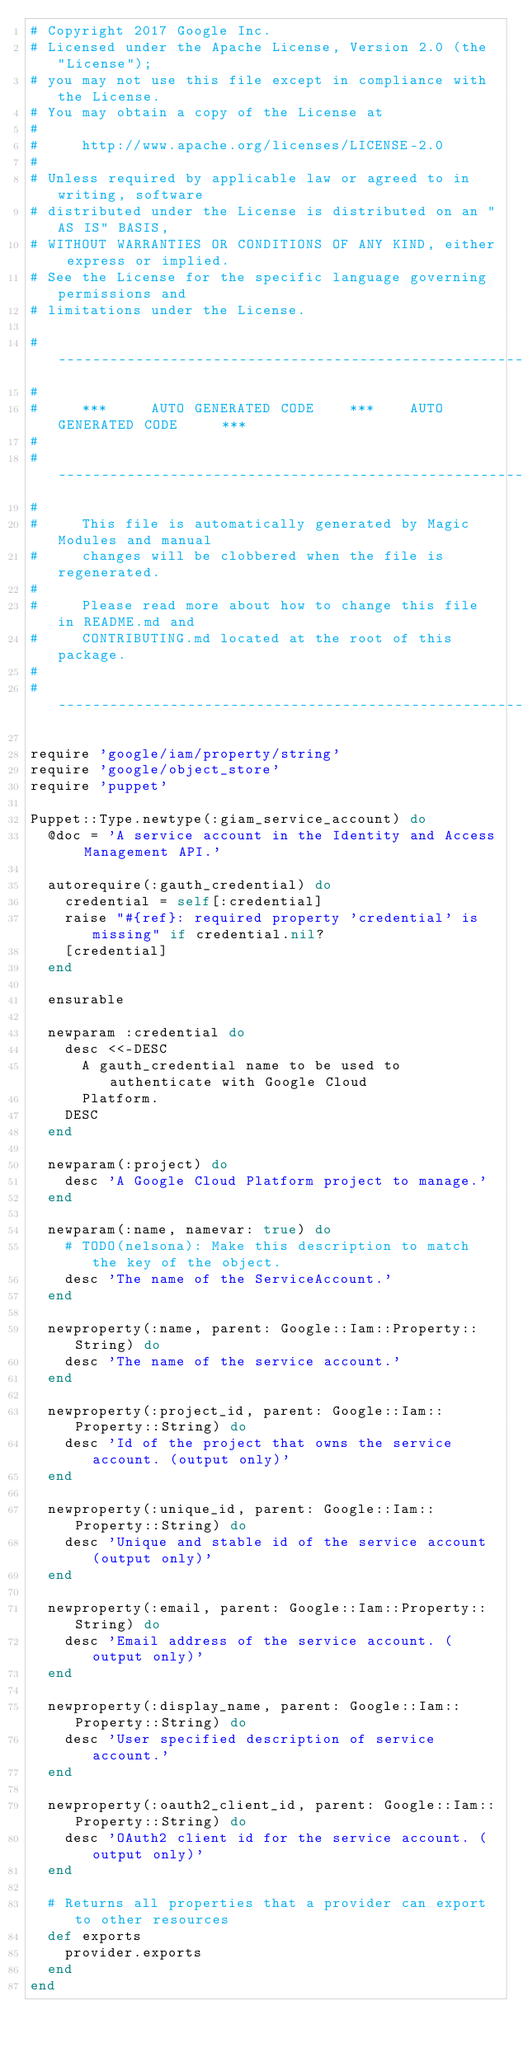<code> <loc_0><loc_0><loc_500><loc_500><_Ruby_># Copyright 2017 Google Inc.
# Licensed under the Apache License, Version 2.0 (the "License");
# you may not use this file except in compliance with the License.
# You may obtain a copy of the License at
#
#     http://www.apache.org/licenses/LICENSE-2.0
#
# Unless required by applicable law or agreed to in writing, software
# distributed under the License is distributed on an "AS IS" BASIS,
# WITHOUT WARRANTIES OR CONDITIONS OF ANY KIND, either express or implied.
# See the License for the specific language governing permissions and
# limitations under the License.

# ----------------------------------------------------------------------------
#
#     ***     AUTO GENERATED CODE    ***    AUTO GENERATED CODE     ***
#
# ----------------------------------------------------------------------------
#
#     This file is automatically generated by Magic Modules and manual
#     changes will be clobbered when the file is regenerated.
#
#     Please read more about how to change this file in README.md and
#     CONTRIBUTING.md located at the root of this package.
#
# ----------------------------------------------------------------------------

require 'google/iam/property/string'
require 'google/object_store'
require 'puppet'

Puppet::Type.newtype(:giam_service_account) do
  @doc = 'A service account in the Identity and Access Management API.'

  autorequire(:gauth_credential) do
    credential = self[:credential]
    raise "#{ref}: required property 'credential' is missing" if credential.nil?
    [credential]
  end

  ensurable

  newparam :credential do
    desc <<-DESC
      A gauth_credential name to be used to authenticate with Google Cloud
      Platform.
    DESC
  end

  newparam(:project) do
    desc 'A Google Cloud Platform project to manage.'
  end

  newparam(:name, namevar: true) do
    # TODO(nelsona): Make this description to match the key of the object.
    desc 'The name of the ServiceAccount.'
  end

  newproperty(:name, parent: Google::Iam::Property::String) do
    desc 'The name of the service account.'
  end

  newproperty(:project_id, parent: Google::Iam::Property::String) do
    desc 'Id of the project that owns the service account. (output only)'
  end

  newproperty(:unique_id, parent: Google::Iam::Property::String) do
    desc 'Unique and stable id of the service account (output only)'
  end

  newproperty(:email, parent: Google::Iam::Property::String) do
    desc 'Email address of the service account. (output only)'
  end

  newproperty(:display_name, parent: Google::Iam::Property::String) do
    desc 'User specified description of service account.'
  end

  newproperty(:oauth2_client_id, parent: Google::Iam::Property::String) do
    desc 'OAuth2 client id for the service account. (output only)'
  end

  # Returns all properties that a provider can export to other resources
  def exports
    provider.exports
  end
end
</code> 